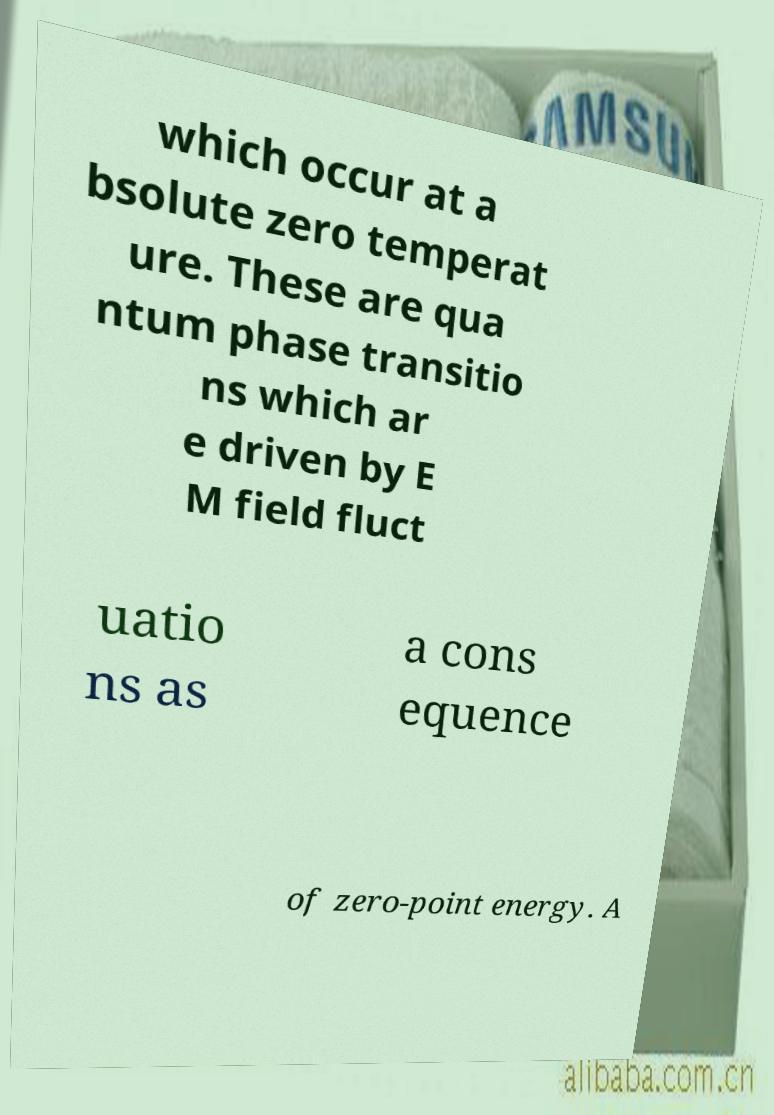I need the written content from this picture converted into text. Can you do that? which occur at a bsolute zero temperat ure. These are qua ntum phase transitio ns which ar e driven by E M field fluct uatio ns as a cons equence of zero-point energy. A 